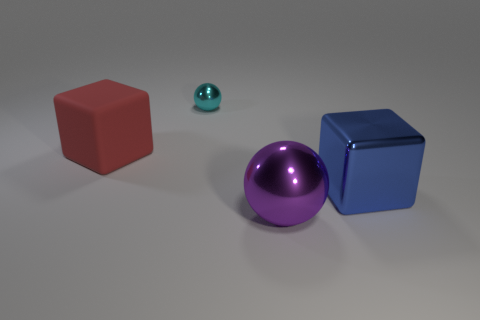Are there the same number of big purple metallic objects that are in front of the purple sphere and large gray rubber things? Yes, there is an equal number of large purple metallic objects and large gray rubber items, with each category having one item present in the image. 